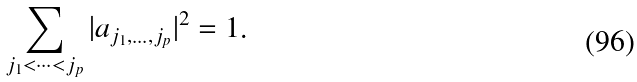Convert formula to latex. <formula><loc_0><loc_0><loc_500><loc_500>\sum _ { j _ { 1 } < \cdots < j _ { p } } | a _ { j _ { 1 } , \dots , j _ { p } } | ^ { 2 } = 1 .</formula> 